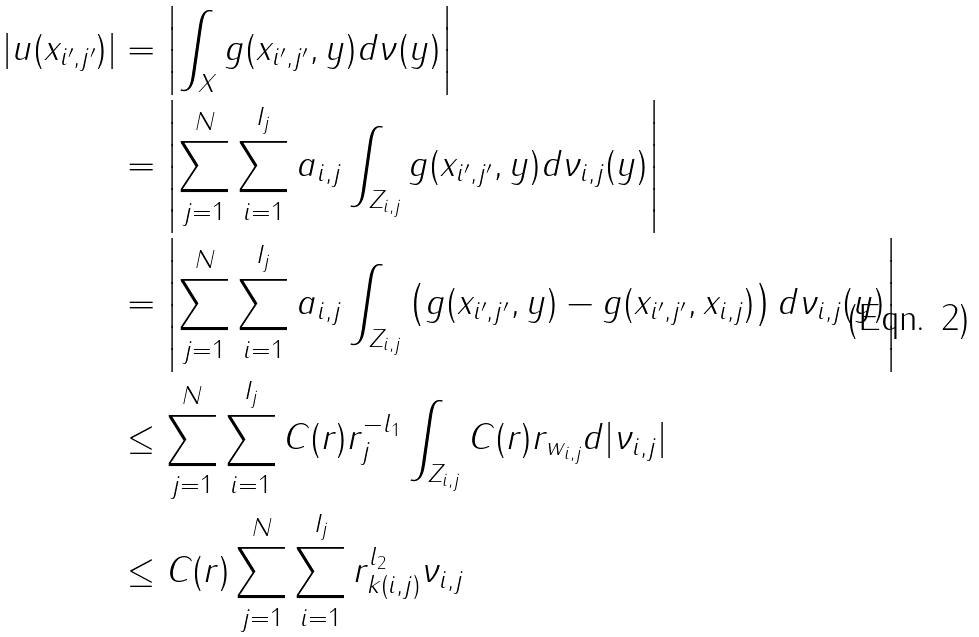<formula> <loc_0><loc_0><loc_500><loc_500>| u ( x _ { i ^ { \prime } , j ^ { \prime } } ) | & = \left | \int _ { X } g ( x _ { i ^ { \prime } , j ^ { \prime } } , y ) d \nu ( y ) \right | \\ & = \left | \sum _ { j = 1 } ^ { N } \sum _ { i = 1 } ^ { I _ { j } } a _ { i , j } \int _ { Z _ { i , j } } g ( x _ { i ^ { \prime } , j ^ { \prime } } , y ) d \nu _ { i , j } ( y ) \right | \\ & = \left | \sum _ { j = 1 } ^ { N } \sum _ { i = 1 } ^ { I _ { j } } a _ { i , j } \int _ { Z _ { i , j } } \left ( g ( x _ { i ^ { \prime } , j ^ { \prime } } , y ) - g ( x _ { i ^ { \prime } , j ^ { \prime } } , x _ { i , j } ) \right ) d \nu _ { i , j } ( y ) \right | \\ & \leq \sum _ { j = 1 } ^ { N } \sum _ { i = 1 } ^ { I _ { j } } C ( r ) r _ { j } ^ { - l _ { 1 } } \int _ { Z _ { i , j } } C ( r ) r _ { w _ { i , j } } d | \nu _ { i , j } | \\ & \leq C ( r ) \sum _ { j = 1 } ^ { N } \sum _ { i = 1 } ^ { I _ { j } } r _ { k ( i , j ) } ^ { l _ { 2 } } \| \nu _ { i , j } \|</formula> 